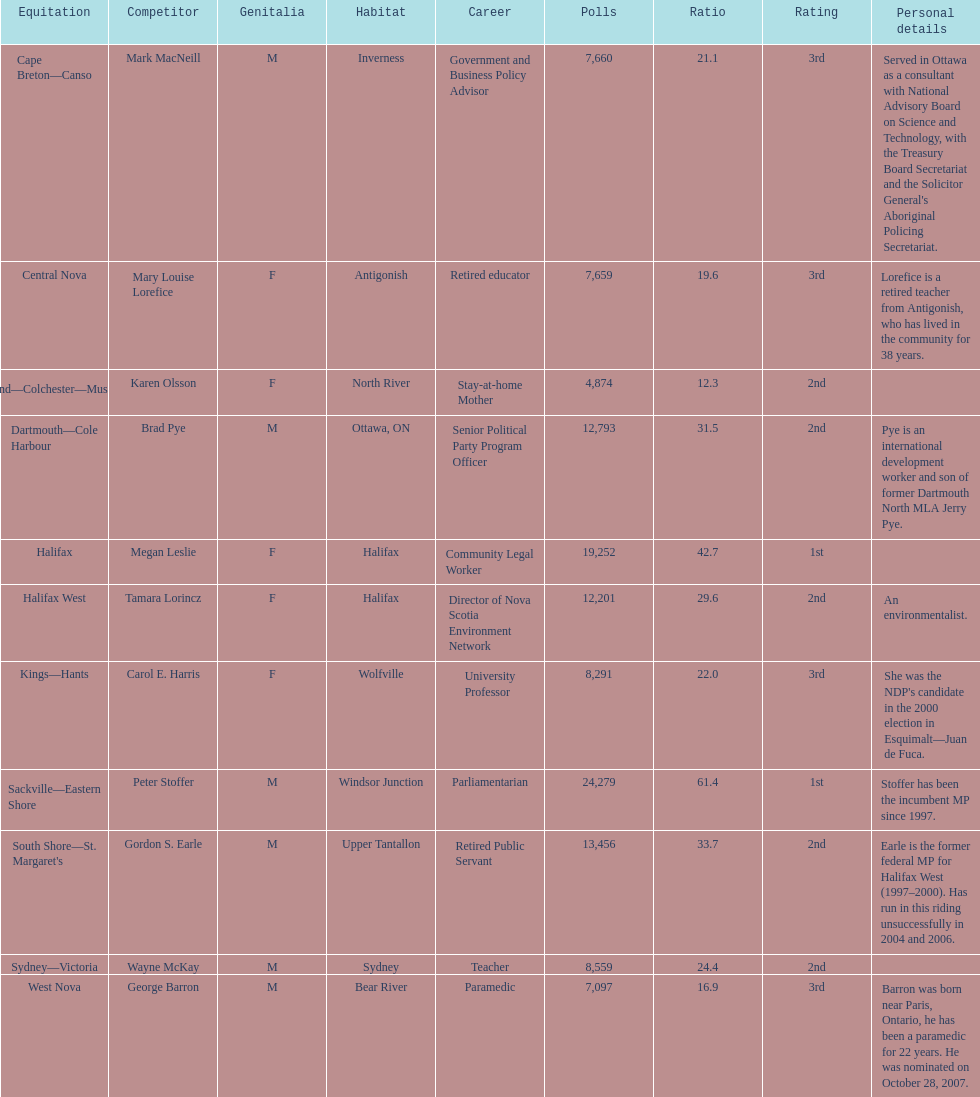How many candidates had more votes than tamara lorincz? 4. 